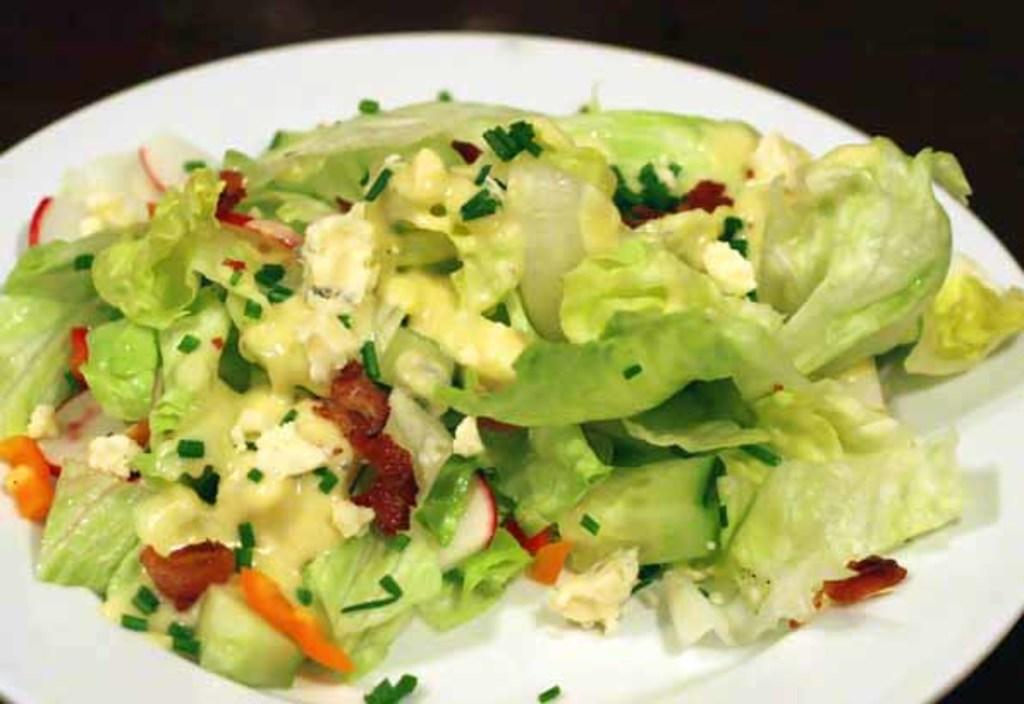What is the color of the plate that holds the food item in the image? The plate is white. What color is the surface on which the white plate is placed? The surface is black. Can you describe the food item on the white plate? Unfortunately, the specific food item is not mentioned in the provided facts. How many sheep are in the flock that is visible in the image? There is no flock of sheep present in the image. 